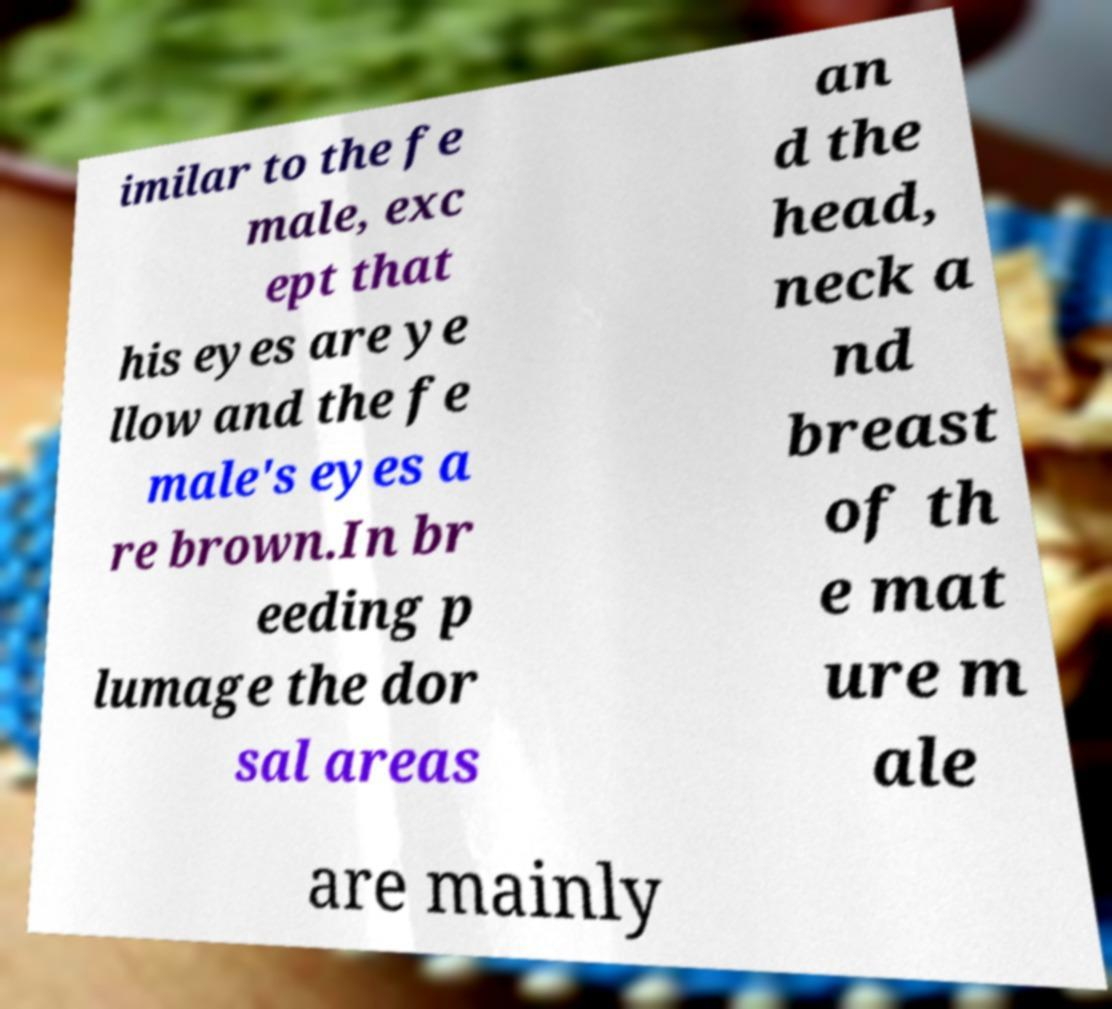Could you extract and type out the text from this image? imilar to the fe male, exc ept that his eyes are ye llow and the fe male's eyes a re brown.In br eeding p lumage the dor sal areas an d the head, neck a nd breast of th e mat ure m ale are mainly 